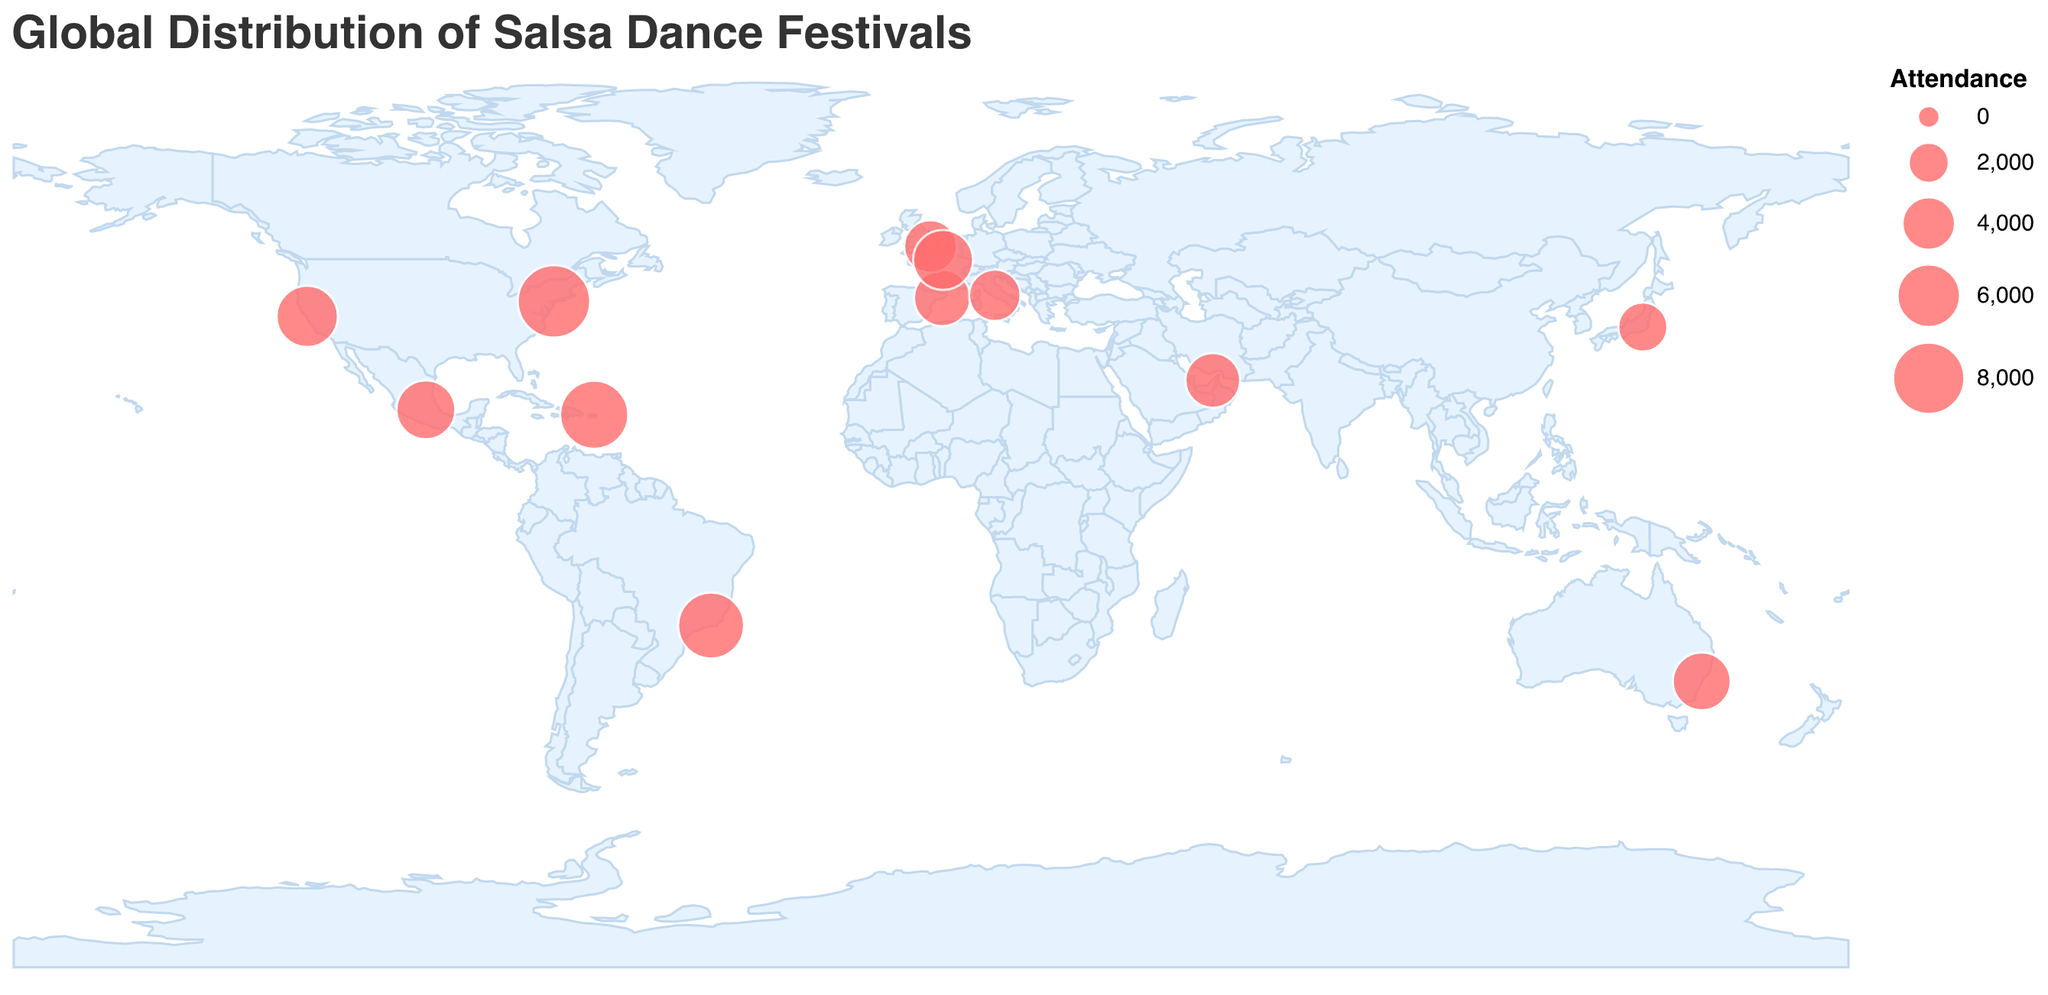What's the title of the figure? The title is displayed at the top of the figure and typically summarizes the main content. Here, it reads "Global Distribution of Salsa Dance Festivals".
Answer: Global Distribution of Salsa Dance Festivals Which festival has the highest attendance? To find the festival with the highest attendance, look at the size of the circles on the map and refer to the tooltip or legend for exact numbers. The largest circle represents the New York Salsa Festival with 8000 attendees.
Answer: New York Salsa Festival How many festivals take place in Europe? Identify the locations of the festivals on the map that fall within European coordinates. The festivals in Europe are located in London, Barcelona, Rome, and Paris.
Answer: 4 Which festival occurs in the month of March? Check the tooltips or list of festivals to find the one taking place in March. The festival occurring in March is the Rio Salsa Carnival.
Answer: Rio Salsa Carnival Which festivals have an attendance greater than 5000? Look for larger circles and their corresponding tooltip information for attendance numbers. The festivals with attendance greater than 5000 are Mexico City International Salsa Congress, New York Salsa Festival, Rio Salsa Carnival, San Francisco Salsa Extravaganza, and Puerto Rico Salsa Congress.
Answer: Mexico City International Salsa Congress, New York Salsa Festival, Rio Salsa Carnival, San Francisco Salsa Extravaganza, Puerto Rico Salsa Congress Which continent has the most salsa festivals? Count the number of festivals within each continent. Europe has the most festivals with London, Barcelona, Rome, and Paris.
Answer: Europe What is the average attendance of festivals held in North America? Identify the festivals in North America (Mexico City, New York, San Francisco, and Puerto Rico) and calculate the average attendance. The attendances are 5000, 8000, 5500, and 7000. The sum is 5000 + 8000 + 5500 + 7000 = 25500. The average is 25500 / 4.
Answer: 6375 How many festivals occur in the second half of the year (July-December)? Count the festivals occurring from July to December by checking the months. The festivals are New York Salsa Festival, San Francisco Salsa Extravaganza, Sydney Salsa Congress, Paris Salsa Gala, and Puerto Rico Salsa Congress.
Answer: 5 Which festival is represented by the smallest circle and where is it located? The smallest circle represents the festival with the lowest attendance. This is the Tokyo Latin Dance Festival, located in Tokyo.
Answer: Tokyo Latin Dance Festival, Tokyo Which festival would you likely not attend if you prefer events with an attendance of at least 4000 people? Check the attendance for all festivals and find those with fewer than 4000 attendees. The Tokyo Latin Dance Festival and Rome Latin Dance Festival have attendances of 3200 and 3600 respectively.
Answer: Tokyo Latin Dance Festival, Rome Latin Dance Festival 